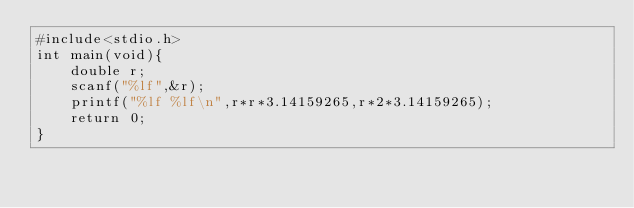Convert code to text. <code><loc_0><loc_0><loc_500><loc_500><_C_>#include<stdio.h>
int main(void){
	double r;
	scanf("%lf",&r);
	printf("%lf %lf\n",r*r*3.14159265,r*2*3.14159265);
	return 0;
}</code> 